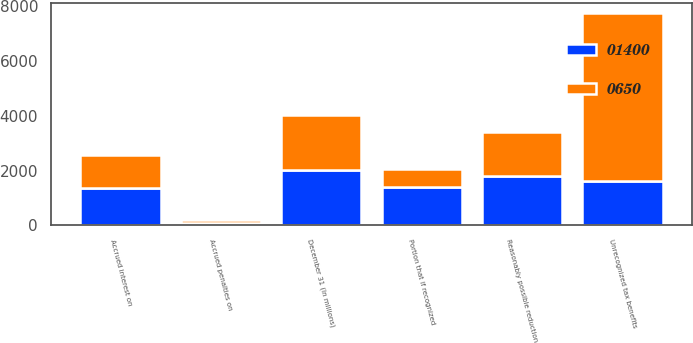Convert chart. <chart><loc_0><loc_0><loc_500><loc_500><stacked_bar_chart><ecel><fcel>December 31 (In millions)<fcel>Unrecognized tax benefits<fcel>Portion that if recognized<fcel>Accrued interest on<fcel>Accrued penalties on<fcel>Reasonably possible reduction<nl><fcel>650<fcel>2010<fcel>6139<fcel>650<fcel>1200<fcel>109<fcel>1600<nl><fcel>1400<fcel>2009<fcel>1600<fcel>1400<fcel>1369<fcel>99<fcel>1800<nl></chart> 